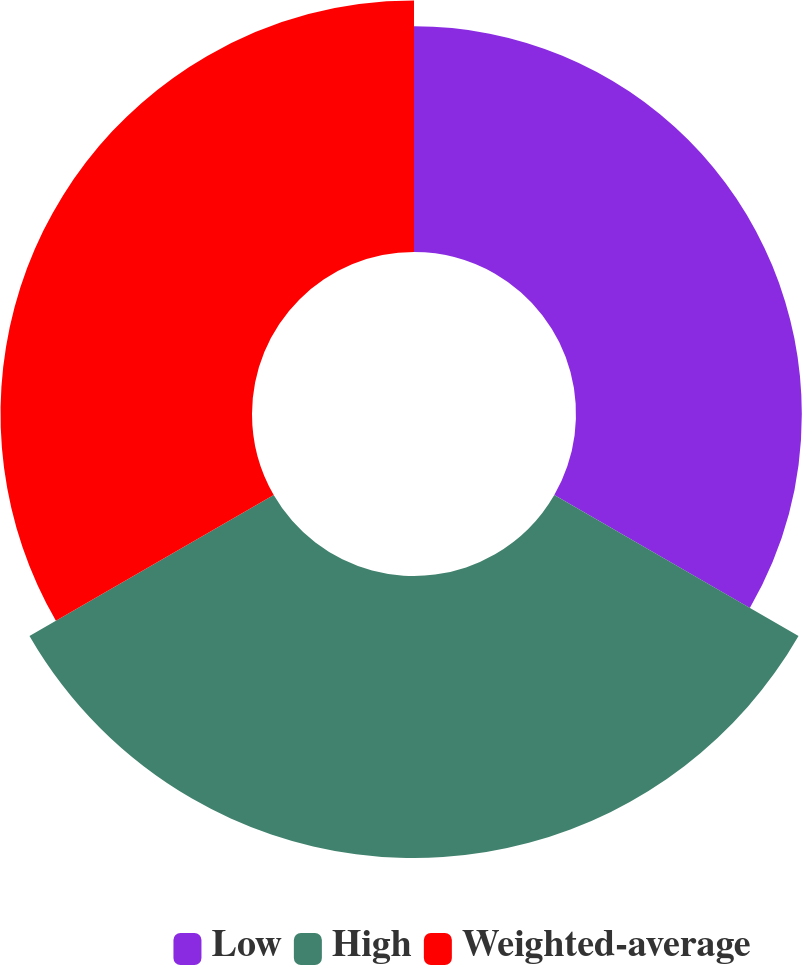Convert chart. <chart><loc_0><loc_0><loc_500><loc_500><pie_chart><fcel>Low<fcel>High<fcel>Weighted-average<nl><fcel>29.74%<fcel>37.14%<fcel>33.12%<nl></chart> 